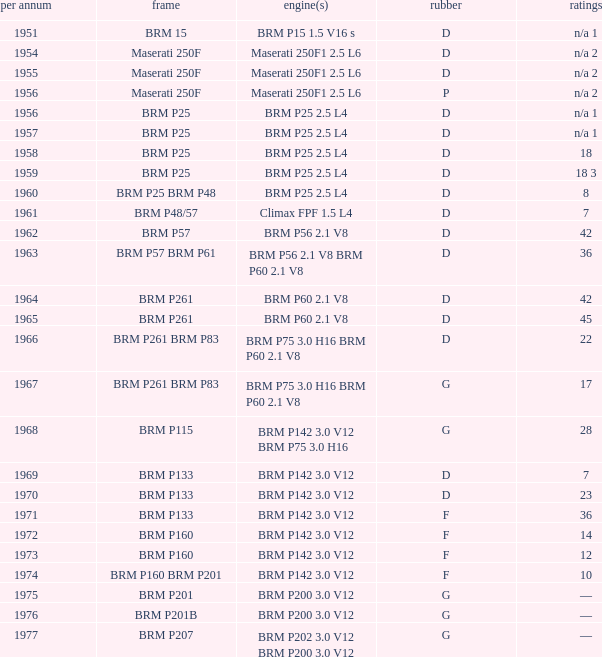Name the chassis for 1970 and tyres of d BRM P133. 